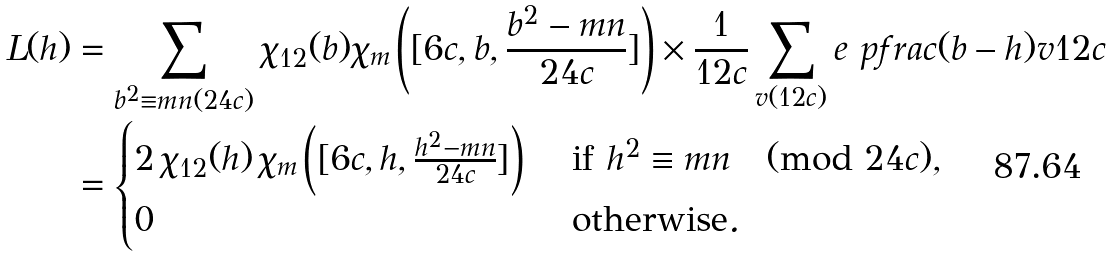<formula> <loc_0><loc_0><loc_500><loc_500>L ( h ) & = \sum _ { b ^ { 2 } \equiv m n ( 2 4 c ) } \chi _ { 1 2 } ( b ) \chi _ { m } \left ( [ 6 c , b , \frac { b ^ { 2 } - m n } { 2 4 c } ] \right ) \times \frac { 1 } { 1 2 c } \sum _ { v ( 1 2 c ) } e \ p f r a c { ( b - h ) v } { 1 2 c } \\ & = \begin{cases} 2 \, \chi _ { 1 2 } ( h ) \, \chi _ { m } \left ( [ 6 c , h , \frac { h ^ { 2 } - m n } { 2 4 c } ] \right ) & \text { if } h ^ { 2 } \equiv m n \pmod { 2 4 c } , \\ 0 & \text { otherwise} . \end{cases}</formula> 